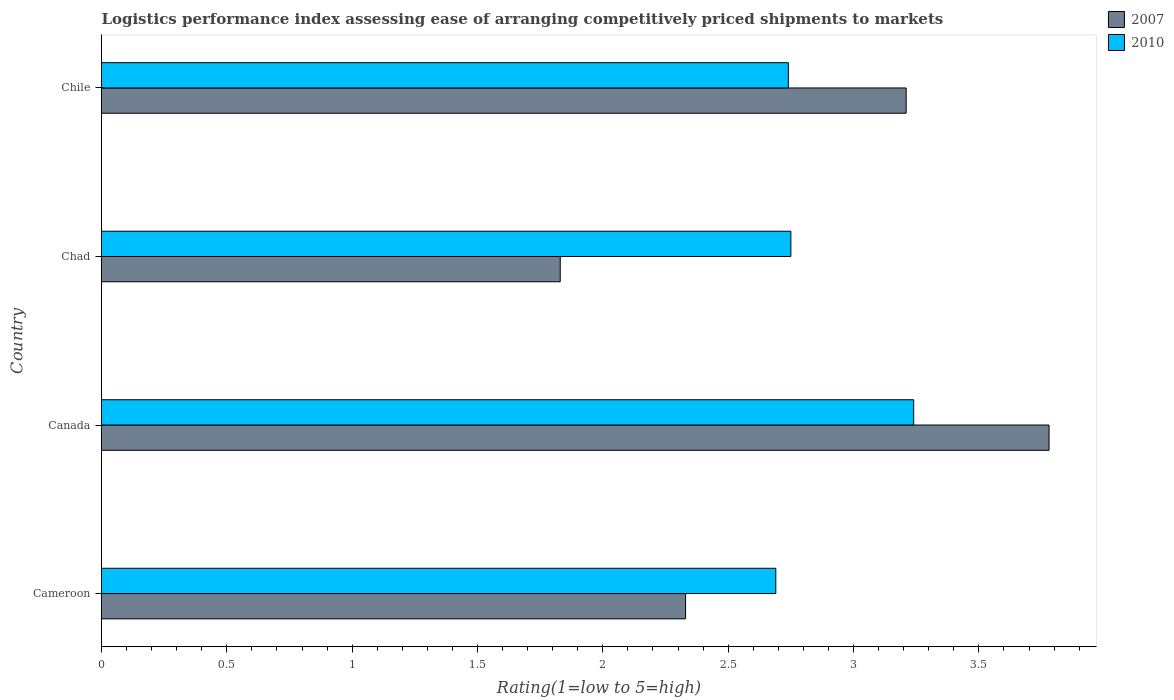How many different coloured bars are there?
Your response must be concise. 2. How many groups of bars are there?
Offer a very short reply. 4. How many bars are there on the 4th tick from the top?
Offer a very short reply. 2. How many bars are there on the 3rd tick from the bottom?
Offer a terse response. 2. What is the label of the 4th group of bars from the top?
Your answer should be compact. Cameroon. What is the Logistic performance index in 2007 in Chad?
Give a very brief answer. 1.83. Across all countries, what is the maximum Logistic performance index in 2007?
Make the answer very short. 3.78. Across all countries, what is the minimum Logistic performance index in 2007?
Provide a short and direct response. 1.83. In which country was the Logistic performance index in 2007 maximum?
Provide a succinct answer. Canada. In which country was the Logistic performance index in 2010 minimum?
Ensure brevity in your answer.  Cameroon. What is the total Logistic performance index in 2007 in the graph?
Give a very brief answer. 11.15. What is the difference between the Logistic performance index in 2007 in Chad and that in Chile?
Give a very brief answer. -1.38. What is the difference between the Logistic performance index in 2010 in Chile and the Logistic performance index in 2007 in Chad?
Ensure brevity in your answer.  0.91. What is the average Logistic performance index in 2007 per country?
Offer a very short reply. 2.79. What is the difference between the Logistic performance index in 2007 and Logistic performance index in 2010 in Cameroon?
Ensure brevity in your answer.  -0.36. In how many countries, is the Logistic performance index in 2007 greater than 0.4 ?
Make the answer very short. 4. What is the ratio of the Logistic performance index in 2007 in Cameroon to that in Chad?
Make the answer very short. 1.27. Is the Logistic performance index in 2007 in Cameroon less than that in Chile?
Offer a terse response. Yes. Is the difference between the Logistic performance index in 2007 in Chad and Chile greater than the difference between the Logistic performance index in 2010 in Chad and Chile?
Your response must be concise. No. What is the difference between the highest and the second highest Logistic performance index in 2010?
Make the answer very short. 0.49. What is the difference between the highest and the lowest Logistic performance index in 2007?
Ensure brevity in your answer.  1.95. In how many countries, is the Logistic performance index in 2007 greater than the average Logistic performance index in 2007 taken over all countries?
Offer a terse response. 2. Is the sum of the Logistic performance index in 2010 in Canada and Chile greater than the maximum Logistic performance index in 2007 across all countries?
Your answer should be very brief. Yes. How many bars are there?
Ensure brevity in your answer.  8. Are all the bars in the graph horizontal?
Make the answer very short. Yes. What is the difference between two consecutive major ticks on the X-axis?
Your answer should be very brief. 0.5. Does the graph contain any zero values?
Your answer should be very brief. No. Does the graph contain grids?
Your response must be concise. No. Where does the legend appear in the graph?
Offer a terse response. Top right. How are the legend labels stacked?
Offer a very short reply. Vertical. What is the title of the graph?
Offer a very short reply. Logistics performance index assessing ease of arranging competitively priced shipments to markets. What is the label or title of the X-axis?
Keep it short and to the point. Rating(1=low to 5=high). What is the Rating(1=low to 5=high) in 2007 in Cameroon?
Your answer should be very brief. 2.33. What is the Rating(1=low to 5=high) of 2010 in Cameroon?
Offer a terse response. 2.69. What is the Rating(1=low to 5=high) in 2007 in Canada?
Your answer should be compact. 3.78. What is the Rating(1=low to 5=high) of 2010 in Canada?
Your answer should be very brief. 3.24. What is the Rating(1=low to 5=high) in 2007 in Chad?
Offer a terse response. 1.83. What is the Rating(1=low to 5=high) of 2010 in Chad?
Give a very brief answer. 2.75. What is the Rating(1=low to 5=high) of 2007 in Chile?
Make the answer very short. 3.21. What is the Rating(1=low to 5=high) in 2010 in Chile?
Your answer should be compact. 2.74. Across all countries, what is the maximum Rating(1=low to 5=high) of 2007?
Keep it short and to the point. 3.78. Across all countries, what is the maximum Rating(1=low to 5=high) in 2010?
Give a very brief answer. 3.24. Across all countries, what is the minimum Rating(1=low to 5=high) in 2007?
Ensure brevity in your answer.  1.83. Across all countries, what is the minimum Rating(1=low to 5=high) in 2010?
Ensure brevity in your answer.  2.69. What is the total Rating(1=low to 5=high) in 2007 in the graph?
Your answer should be compact. 11.15. What is the total Rating(1=low to 5=high) of 2010 in the graph?
Offer a very short reply. 11.42. What is the difference between the Rating(1=low to 5=high) in 2007 in Cameroon and that in Canada?
Provide a succinct answer. -1.45. What is the difference between the Rating(1=low to 5=high) of 2010 in Cameroon and that in Canada?
Offer a terse response. -0.55. What is the difference between the Rating(1=low to 5=high) in 2010 in Cameroon and that in Chad?
Make the answer very short. -0.06. What is the difference between the Rating(1=low to 5=high) in 2007 in Cameroon and that in Chile?
Keep it short and to the point. -0.88. What is the difference between the Rating(1=low to 5=high) of 2007 in Canada and that in Chad?
Make the answer very short. 1.95. What is the difference between the Rating(1=low to 5=high) in 2010 in Canada and that in Chad?
Offer a terse response. 0.49. What is the difference between the Rating(1=low to 5=high) of 2007 in Canada and that in Chile?
Your answer should be compact. 0.57. What is the difference between the Rating(1=low to 5=high) of 2007 in Chad and that in Chile?
Ensure brevity in your answer.  -1.38. What is the difference between the Rating(1=low to 5=high) of 2010 in Chad and that in Chile?
Ensure brevity in your answer.  0.01. What is the difference between the Rating(1=low to 5=high) of 2007 in Cameroon and the Rating(1=low to 5=high) of 2010 in Canada?
Offer a very short reply. -0.91. What is the difference between the Rating(1=low to 5=high) of 2007 in Cameroon and the Rating(1=low to 5=high) of 2010 in Chad?
Ensure brevity in your answer.  -0.42. What is the difference between the Rating(1=low to 5=high) of 2007 in Cameroon and the Rating(1=low to 5=high) of 2010 in Chile?
Make the answer very short. -0.41. What is the difference between the Rating(1=low to 5=high) of 2007 in Canada and the Rating(1=low to 5=high) of 2010 in Chile?
Provide a succinct answer. 1.04. What is the difference between the Rating(1=low to 5=high) in 2007 in Chad and the Rating(1=low to 5=high) in 2010 in Chile?
Ensure brevity in your answer.  -0.91. What is the average Rating(1=low to 5=high) in 2007 per country?
Ensure brevity in your answer.  2.79. What is the average Rating(1=low to 5=high) in 2010 per country?
Your answer should be very brief. 2.85. What is the difference between the Rating(1=low to 5=high) of 2007 and Rating(1=low to 5=high) of 2010 in Cameroon?
Your response must be concise. -0.36. What is the difference between the Rating(1=low to 5=high) of 2007 and Rating(1=low to 5=high) of 2010 in Canada?
Your answer should be compact. 0.54. What is the difference between the Rating(1=low to 5=high) in 2007 and Rating(1=low to 5=high) in 2010 in Chad?
Your answer should be compact. -0.92. What is the difference between the Rating(1=low to 5=high) in 2007 and Rating(1=low to 5=high) in 2010 in Chile?
Your response must be concise. 0.47. What is the ratio of the Rating(1=low to 5=high) in 2007 in Cameroon to that in Canada?
Your answer should be very brief. 0.62. What is the ratio of the Rating(1=low to 5=high) in 2010 in Cameroon to that in Canada?
Offer a very short reply. 0.83. What is the ratio of the Rating(1=low to 5=high) in 2007 in Cameroon to that in Chad?
Make the answer very short. 1.27. What is the ratio of the Rating(1=low to 5=high) of 2010 in Cameroon to that in Chad?
Offer a terse response. 0.98. What is the ratio of the Rating(1=low to 5=high) of 2007 in Cameroon to that in Chile?
Keep it short and to the point. 0.73. What is the ratio of the Rating(1=low to 5=high) in 2010 in Cameroon to that in Chile?
Ensure brevity in your answer.  0.98. What is the ratio of the Rating(1=low to 5=high) of 2007 in Canada to that in Chad?
Keep it short and to the point. 2.07. What is the ratio of the Rating(1=low to 5=high) of 2010 in Canada to that in Chad?
Offer a very short reply. 1.18. What is the ratio of the Rating(1=low to 5=high) in 2007 in Canada to that in Chile?
Provide a short and direct response. 1.18. What is the ratio of the Rating(1=low to 5=high) of 2010 in Canada to that in Chile?
Keep it short and to the point. 1.18. What is the ratio of the Rating(1=low to 5=high) in 2007 in Chad to that in Chile?
Your answer should be compact. 0.57. What is the ratio of the Rating(1=low to 5=high) of 2010 in Chad to that in Chile?
Give a very brief answer. 1. What is the difference between the highest and the second highest Rating(1=low to 5=high) in 2007?
Offer a very short reply. 0.57. What is the difference between the highest and the second highest Rating(1=low to 5=high) in 2010?
Provide a succinct answer. 0.49. What is the difference between the highest and the lowest Rating(1=low to 5=high) of 2007?
Provide a short and direct response. 1.95. What is the difference between the highest and the lowest Rating(1=low to 5=high) of 2010?
Your answer should be compact. 0.55. 